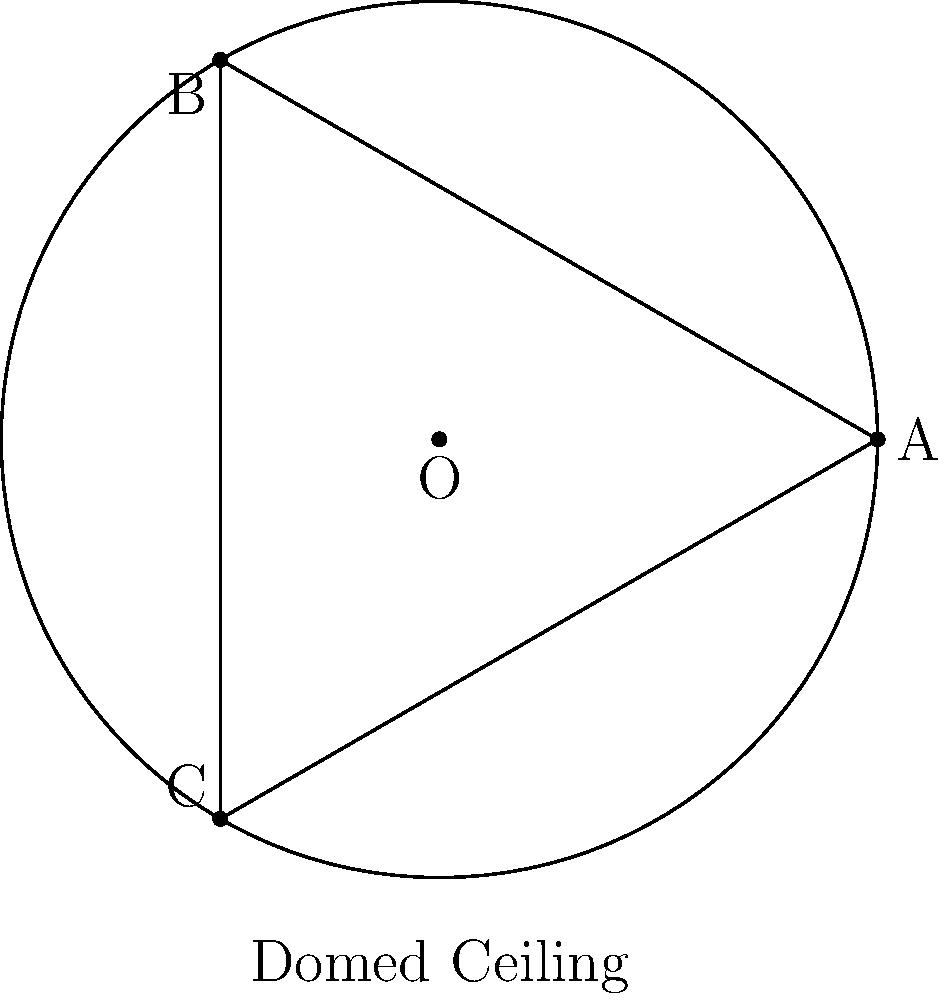In the Shattered Globe Theatre's newly renovated domed ceiling, a triangular design is painted on the elliptic surface. If each side of this triangle is a great circle arc, what is the sum of the interior angles of this triangle? To solve this problem, we need to understand the properties of triangles on elliptic surfaces:

1. In elliptic geometry, such as on the surface of a sphere or dome, the sum of angles in a triangle is always greater than 180°.

2. The excess of the sum over 180° is proportional to the area of the triangle relative to the total surface area of the sphere.

3. For a full sphere, the formula for the sum of angles in a triangle is:

   $$S = 180° + \frac{A}{R^2} \cdot \frac{180°}{\pi}$$

   Where $S$ is the sum of angles, $A$ is the area of the triangle, and $R$ is the radius of the sphere.

4. In our case, we're dealing with a hemisphere (the dome), so the maximum possible area of the triangle is half that of a full sphere.

5. The maximum sum of angles in a triangle on a hemisphere occurs when the triangle covers the entire hemisphere, which is equivalent to a triangle on a sphere with two right angles (90°) and the third angle being 180°.

6. Therefore, the sum of angles in this case would be:

   $$S_{max} = 90° + 90° + 180° = 360°$$

7. This maximum sum occurs regardless of the size of the sphere or dome.

Thus, for any triangle on the elliptic surface of the domed ceiling, the sum of its interior angles will be greater than 180° but less than or equal to 360°.
Answer: Between 180° and 360° 